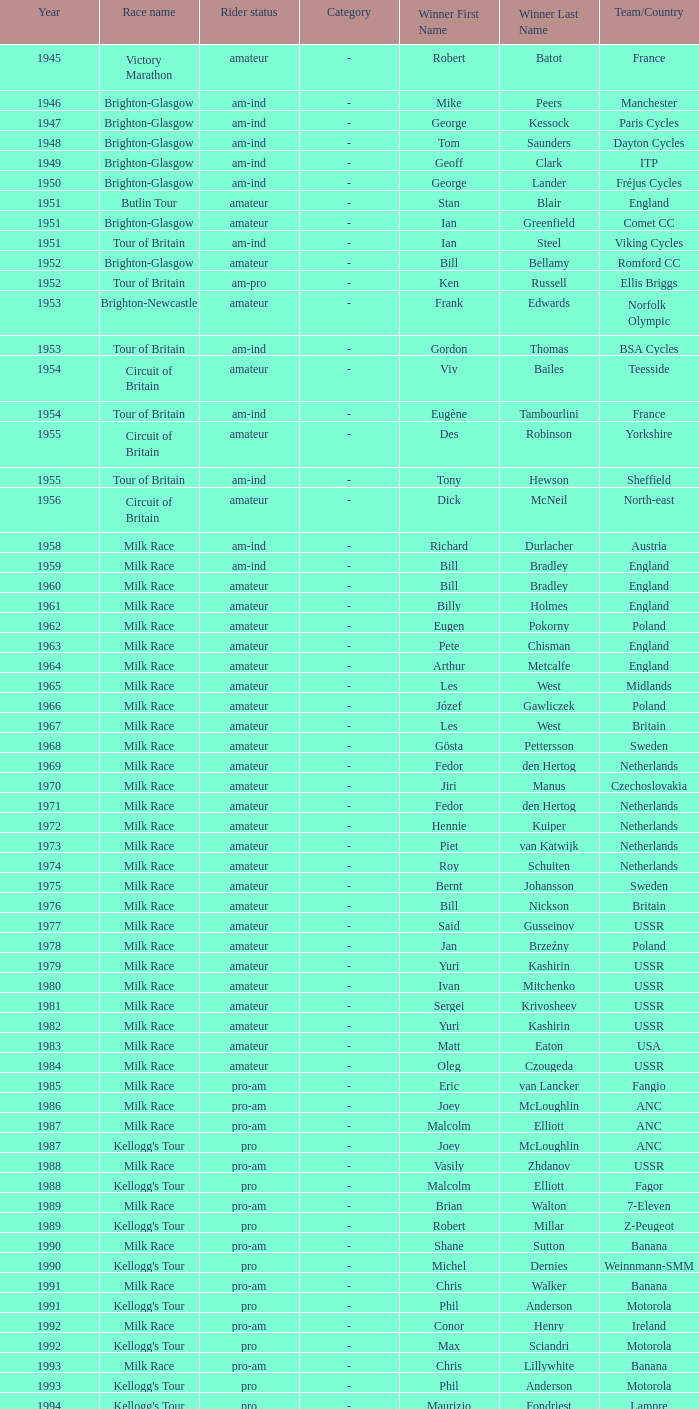What is the latest year when Phil Anderson won? 1993.0. 